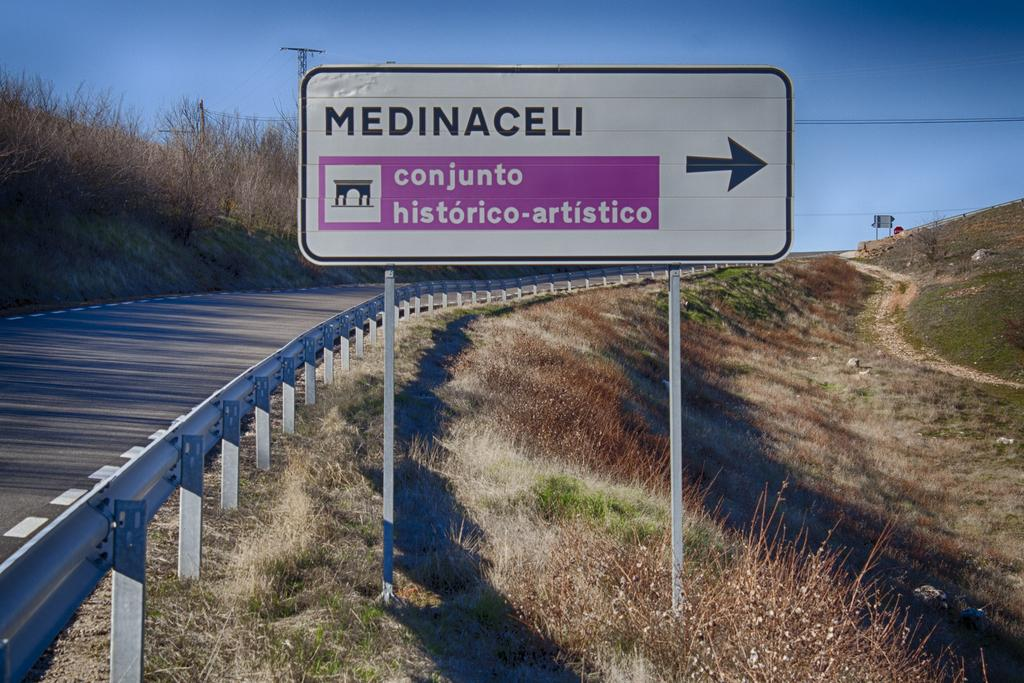<image>
Give a short and clear explanation of the subsequent image. A rural highway has a white and pink sign that says Medinaceli conjunto historico-artistico. 